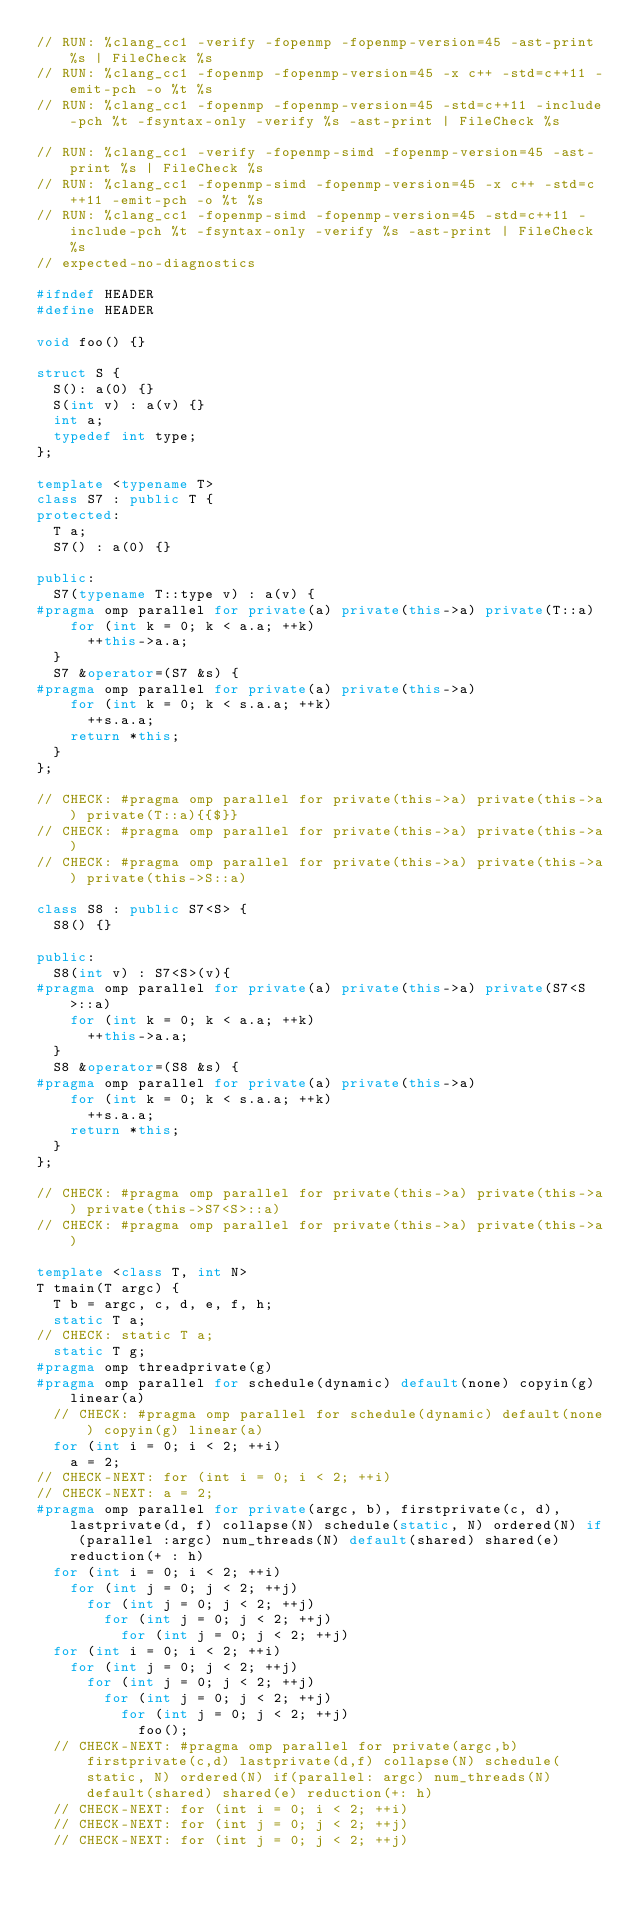<code> <loc_0><loc_0><loc_500><loc_500><_C++_>// RUN: %clang_cc1 -verify -fopenmp -fopenmp-version=45 -ast-print %s | FileCheck %s
// RUN: %clang_cc1 -fopenmp -fopenmp-version=45 -x c++ -std=c++11 -emit-pch -o %t %s
// RUN: %clang_cc1 -fopenmp -fopenmp-version=45 -std=c++11 -include-pch %t -fsyntax-only -verify %s -ast-print | FileCheck %s

// RUN: %clang_cc1 -verify -fopenmp-simd -fopenmp-version=45 -ast-print %s | FileCheck %s
// RUN: %clang_cc1 -fopenmp-simd -fopenmp-version=45 -x c++ -std=c++11 -emit-pch -o %t %s
// RUN: %clang_cc1 -fopenmp-simd -fopenmp-version=45 -std=c++11 -include-pch %t -fsyntax-only -verify %s -ast-print | FileCheck %s
// expected-no-diagnostics

#ifndef HEADER
#define HEADER

void foo() {}

struct S {
  S(): a(0) {}
  S(int v) : a(v) {}
  int a;
  typedef int type;
};

template <typename T>
class S7 : public T {
protected:
  T a;
  S7() : a(0) {}

public:
  S7(typename T::type v) : a(v) {
#pragma omp parallel for private(a) private(this->a) private(T::a)
    for (int k = 0; k < a.a; ++k)
      ++this->a.a;
  }
  S7 &operator=(S7 &s) {
#pragma omp parallel for private(a) private(this->a)
    for (int k = 0; k < s.a.a; ++k)
      ++s.a.a;
    return *this;
  }
};

// CHECK: #pragma omp parallel for private(this->a) private(this->a) private(T::a){{$}}
// CHECK: #pragma omp parallel for private(this->a) private(this->a)
// CHECK: #pragma omp parallel for private(this->a) private(this->a) private(this->S::a)

class S8 : public S7<S> {
  S8() {}

public:
  S8(int v) : S7<S>(v){
#pragma omp parallel for private(a) private(this->a) private(S7<S>::a)
    for (int k = 0; k < a.a; ++k)
      ++this->a.a;
  }
  S8 &operator=(S8 &s) {
#pragma omp parallel for private(a) private(this->a)
    for (int k = 0; k < s.a.a; ++k)
      ++s.a.a;
    return *this;
  }
};

// CHECK: #pragma omp parallel for private(this->a) private(this->a) private(this->S7<S>::a)
// CHECK: #pragma omp parallel for private(this->a) private(this->a)

template <class T, int N>
T tmain(T argc) {
  T b = argc, c, d, e, f, h;
  static T a;
// CHECK: static T a;
  static T g;
#pragma omp threadprivate(g)
#pragma omp parallel for schedule(dynamic) default(none) copyin(g) linear(a)
  // CHECK: #pragma omp parallel for schedule(dynamic) default(none) copyin(g) linear(a)
  for (int i = 0; i < 2; ++i)
    a = 2;
// CHECK-NEXT: for (int i = 0; i < 2; ++i)
// CHECK-NEXT: a = 2;
#pragma omp parallel for private(argc, b), firstprivate(c, d), lastprivate(d, f) collapse(N) schedule(static, N) ordered(N) if (parallel :argc) num_threads(N) default(shared) shared(e) reduction(+ : h)
  for (int i = 0; i < 2; ++i)
    for (int j = 0; j < 2; ++j)
      for (int j = 0; j < 2; ++j)
        for (int j = 0; j < 2; ++j)
          for (int j = 0; j < 2; ++j)
  for (int i = 0; i < 2; ++i)
    for (int j = 0; j < 2; ++j)
      for (int j = 0; j < 2; ++j)
        for (int j = 0; j < 2; ++j)
          for (int j = 0; j < 2; ++j)
            foo();
  // CHECK-NEXT: #pragma omp parallel for private(argc,b) firstprivate(c,d) lastprivate(d,f) collapse(N) schedule(static, N) ordered(N) if(parallel: argc) num_threads(N) default(shared) shared(e) reduction(+: h)
  // CHECK-NEXT: for (int i = 0; i < 2; ++i)
  // CHECK-NEXT: for (int j = 0; j < 2; ++j)
  // CHECK-NEXT: for (int j = 0; j < 2; ++j)</code> 